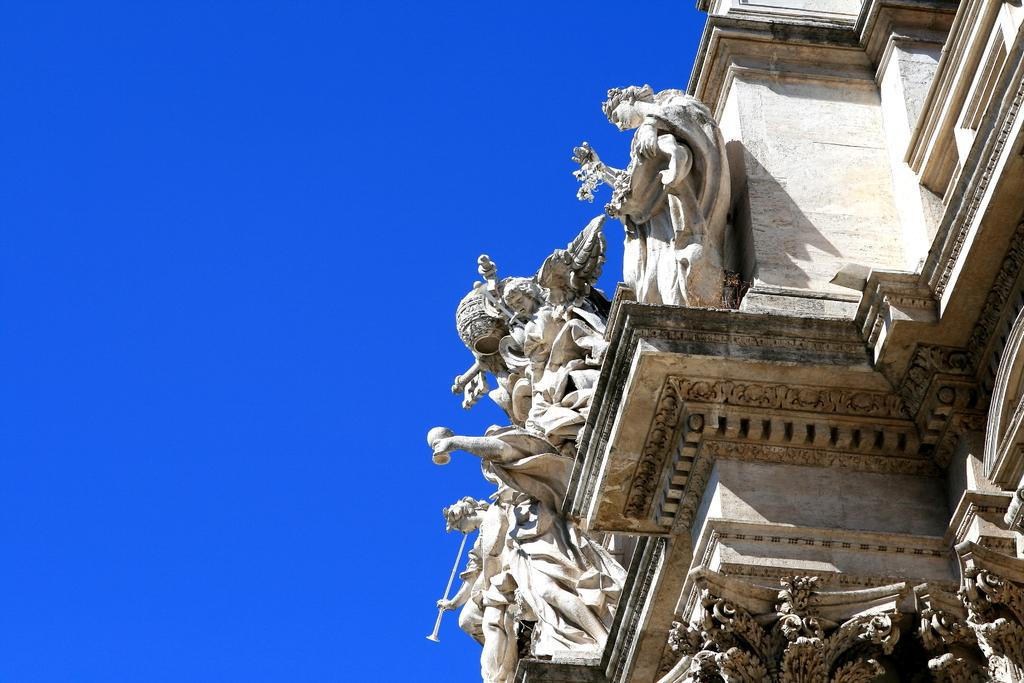What is the main subject of the image? The main subject of the image is a statue of persons. Where is the statue located? The statue is on a building. What can be seen on the left side of the image? The sky is visible on the left side of the image. How many tickets are needed to enter the statue in the image? There are no tickets mentioned or implied in the image, as it features a statue on a building. 